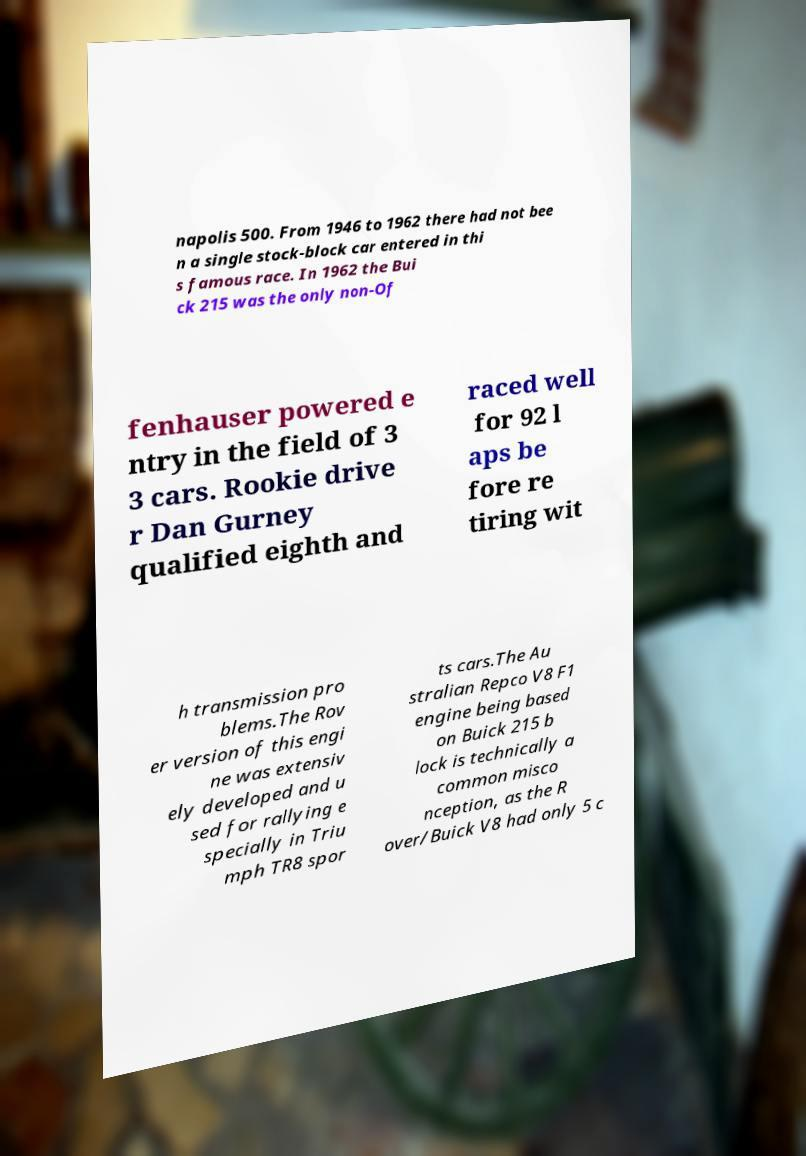Can you accurately transcribe the text from the provided image for me? napolis 500. From 1946 to 1962 there had not bee n a single stock-block car entered in thi s famous race. In 1962 the Bui ck 215 was the only non-Of fenhauser powered e ntry in the field of 3 3 cars. Rookie drive r Dan Gurney qualified eighth and raced well for 92 l aps be fore re tiring wit h transmission pro blems.The Rov er version of this engi ne was extensiv ely developed and u sed for rallying e specially in Triu mph TR8 spor ts cars.The Au stralian Repco V8 F1 engine being based on Buick 215 b lock is technically a common misco nception, as the R over/Buick V8 had only 5 c 